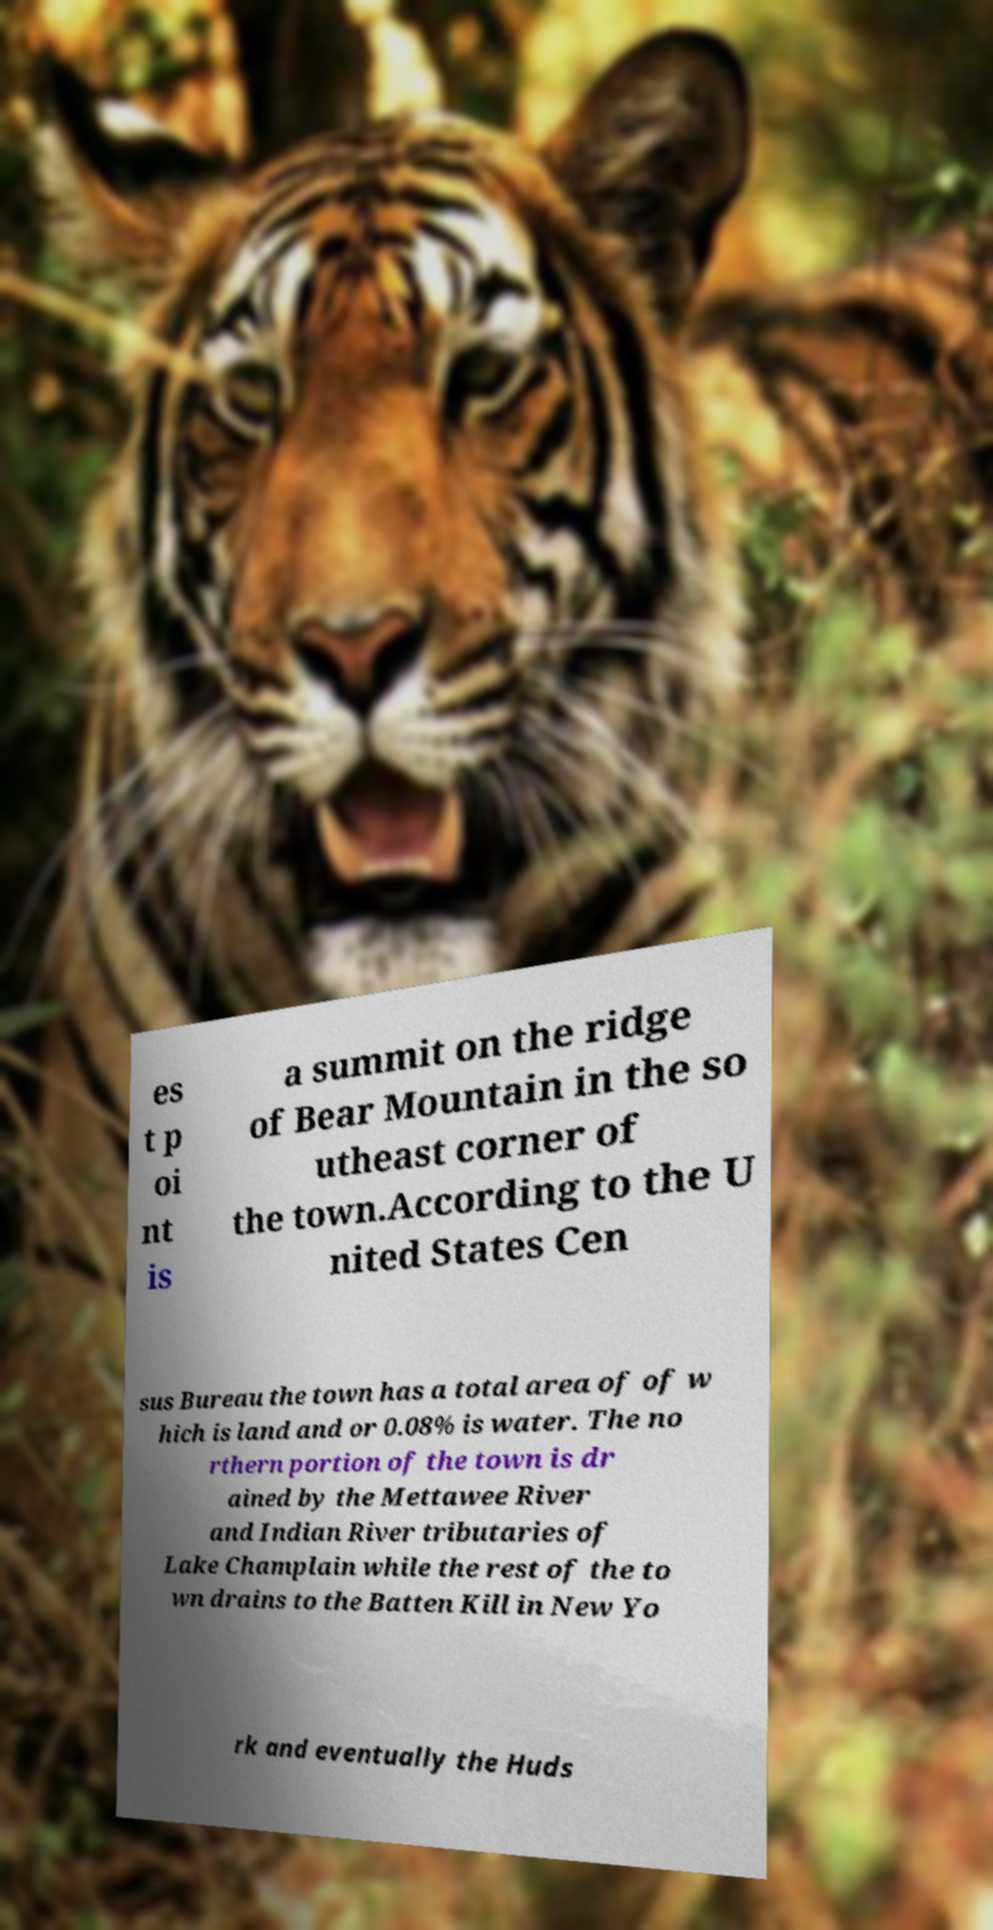Could you extract and type out the text from this image? es t p oi nt is a summit on the ridge of Bear Mountain in the so utheast corner of the town.According to the U nited States Cen sus Bureau the town has a total area of of w hich is land and or 0.08% is water. The no rthern portion of the town is dr ained by the Mettawee River and Indian River tributaries of Lake Champlain while the rest of the to wn drains to the Batten Kill in New Yo rk and eventually the Huds 